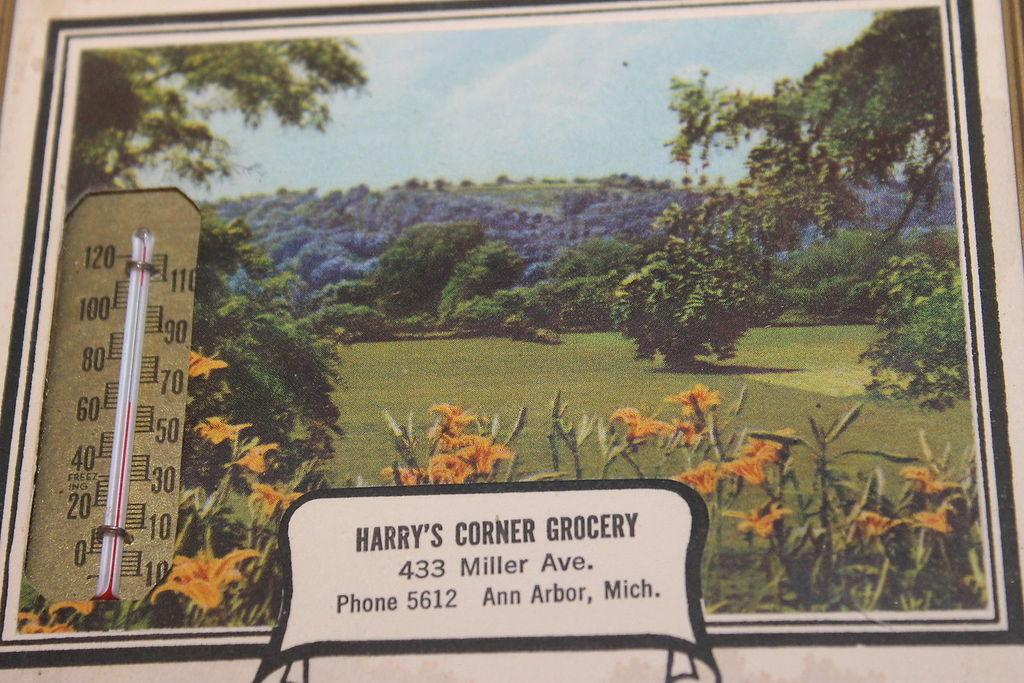<image>
Write a terse but informative summary of the picture. The old picture is from Harry's Corner Grocery 